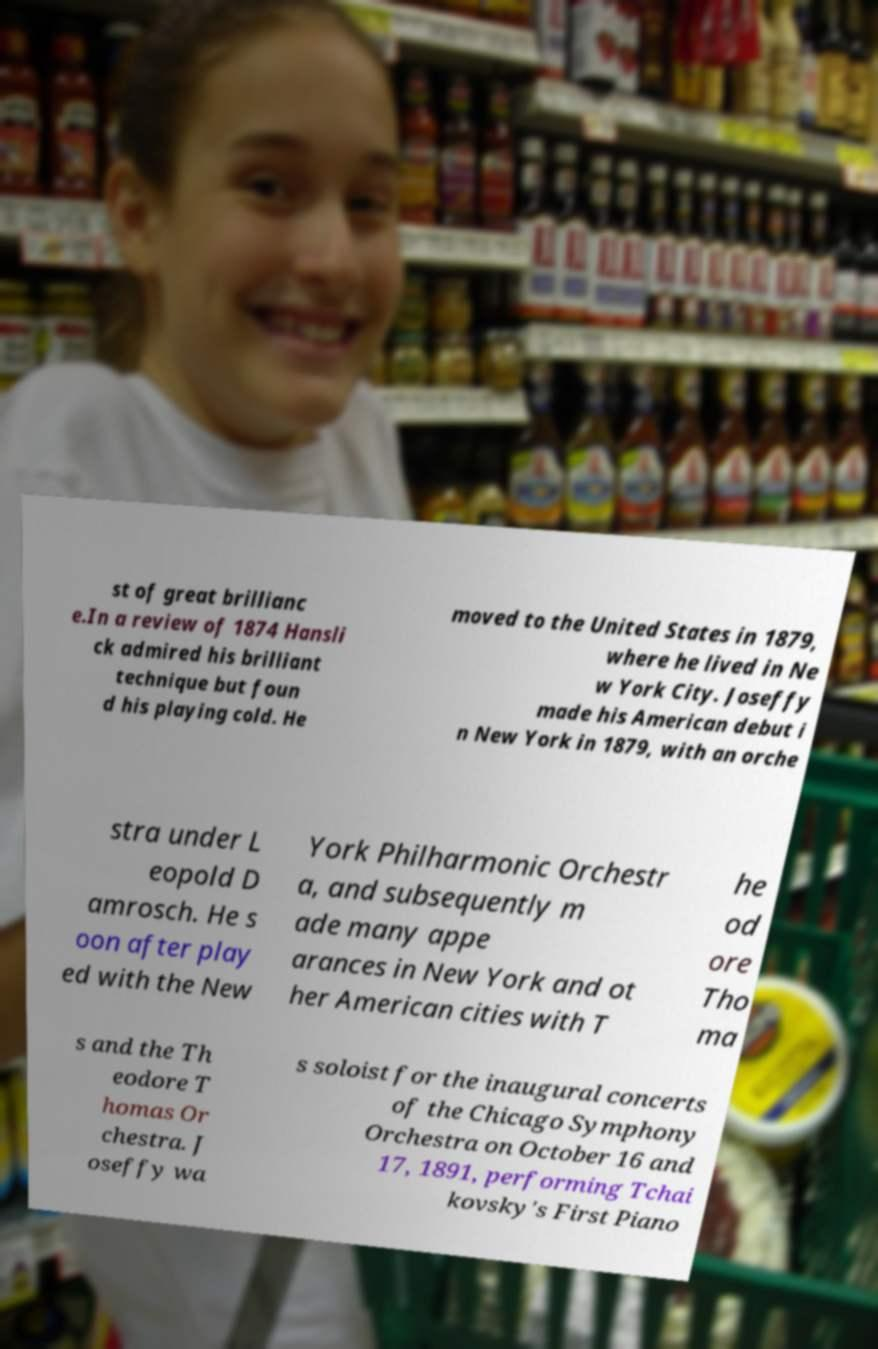I need the written content from this picture converted into text. Can you do that? st of great brillianc e.In a review of 1874 Hansli ck admired his brilliant technique but foun d his playing cold. He moved to the United States in 1879, where he lived in Ne w York City. Joseffy made his American debut i n New York in 1879, with an orche stra under L eopold D amrosch. He s oon after play ed with the New York Philharmonic Orchestr a, and subsequently m ade many appe arances in New York and ot her American cities with T he od ore Tho ma s and the Th eodore T homas Or chestra. J oseffy wa s soloist for the inaugural concerts of the Chicago Symphony Orchestra on October 16 and 17, 1891, performing Tchai kovsky's First Piano 